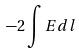<formula> <loc_0><loc_0><loc_500><loc_500>- 2 \int E d l</formula> 